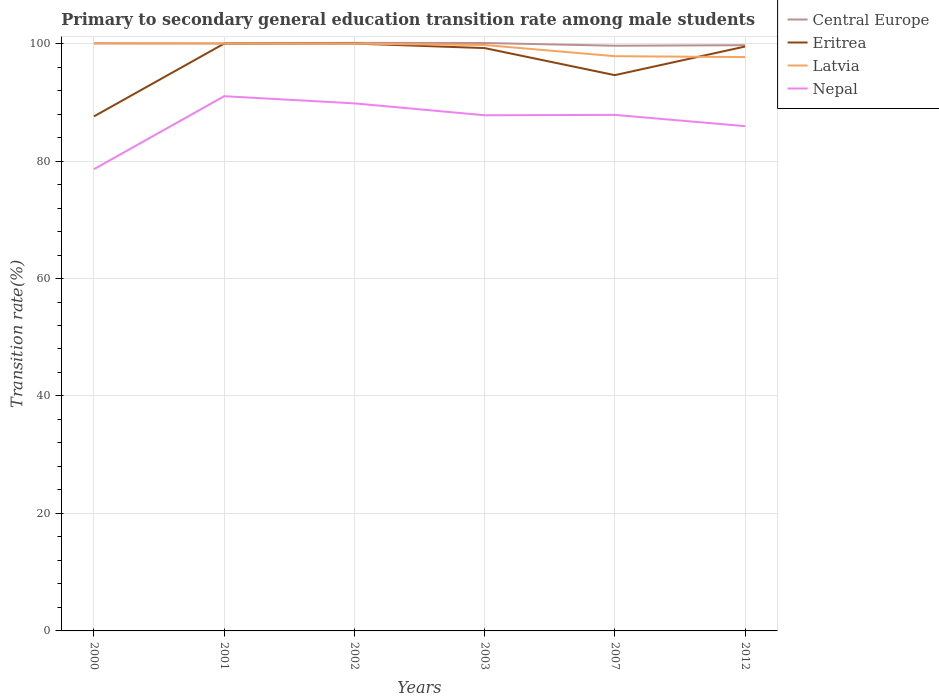How many different coloured lines are there?
Ensure brevity in your answer.  4. Does the line corresponding to Central Europe intersect with the line corresponding to Eritrea?
Ensure brevity in your answer.  No. Is the number of lines equal to the number of legend labels?
Offer a terse response. Yes. Across all years, what is the maximum transition rate in Eritrea?
Make the answer very short. 87.6. In which year was the transition rate in Latvia maximum?
Offer a terse response. 2012. What is the total transition rate in Eritrea in the graph?
Provide a succinct answer. 0.5. What is the difference between the highest and the second highest transition rate in Latvia?
Offer a very short reply. 2.3. Is the transition rate in Latvia strictly greater than the transition rate in Eritrea over the years?
Your answer should be compact. No. Are the values on the major ticks of Y-axis written in scientific E-notation?
Ensure brevity in your answer.  No. Does the graph contain grids?
Your answer should be compact. Yes. Where does the legend appear in the graph?
Ensure brevity in your answer.  Top right. How many legend labels are there?
Give a very brief answer. 4. What is the title of the graph?
Give a very brief answer. Primary to secondary general education transition rate among male students. Does "Trinidad and Tobago" appear as one of the legend labels in the graph?
Your answer should be compact. No. What is the label or title of the Y-axis?
Your response must be concise. Transition rate(%). What is the Transition rate(%) in Central Europe in 2000?
Your answer should be compact. 100.06. What is the Transition rate(%) of Eritrea in 2000?
Offer a very short reply. 87.6. What is the Transition rate(%) in Nepal in 2000?
Your response must be concise. 78.61. What is the Transition rate(%) in Central Europe in 2001?
Your response must be concise. 100.03. What is the Transition rate(%) in Nepal in 2001?
Keep it short and to the point. 91.04. What is the Transition rate(%) of Central Europe in 2002?
Your response must be concise. 100.12. What is the Transition rate(%) in Latvia in 2002?
Provide a succinct answer. 99.99. What is the Transition rate(%) in Nepal in 2002?
Offer a terse response. 89.82. What is the Transition rate(%) of Central Europe in 2003?
Keep it short and to the point. 100.1. What is the Transition rate(%) of Eritrea in 2003?
Give a very brief answer. 99.23. What is the Transition rate(%) of Latvia in 2003?
Offer a terse response. 99.76. What is the Transition rate(%) of Nepal in 2003?
Offer a very short reply. 87.8. What is the Transition rate(%) of Central Europe in 2007?
Provide a succinct answer. 99.63. What is the Transition rate(%) in Eritrea in 2007?
Provide a short and direct response. 94.62. What is the Transition rate(%) in Latvia in 2007?
Your response must be concise. 97.85. What is the Transition rate(%) of Nepal in 2007?
Offer a very short reply. 87.86. What is the Transition rate(%) of Central Europe in 2012?
Your response must be concise. 99.73. What is the Transition rate(%) of Eritrea in 2012?
Provide a succinct answer. 99.5. What is the Transition rate(%) of Latvia in 2012?
Ensure brevity in your answer.  97.7. What is the Transition rate(%) of Nepal in 2012?
Provide a short and direct response. 85.94. Across all years, what is the maximum Transition rate(%) in Central Europe?
Provide a succinct answer. 100.12. Across all years, what is the maximum Transition rate(%) of Eritrea?
Give a very brief answer. 100. Across all years, what is the maximum Transition rate(%) of Nepal?
Give a very brief answer. 91.04. Across all years, what is the minimum Transition rate(%) of Central Europe?
Keep it short and to the point. 99.63. Across all years, what is the minimum Transition rate(%) in Eritrea?
Offer a terse response. 87.6. Across all years, what is the minimum Transition rate(%) of Latvia?
Your response must be concise. 97.7. Across all years, what is the minimum Transition rate(%) in Nepal?
Keep it short and to the point. 78.61. What is the total Transition rate(%) in Central Europe in the graph?
Offer a very short reply. 599.67. What is the total Transition rate(%) in Eritrea in the graph?
Offer a very short reply. 580.96. What is the total Transition rate(%) of Latvia in the graph?
Offer a terse response. 595.3. What is the total Transition rate(%) in Nepal in the graph?
Give a very brief answer. 521.08. What is the difference between the Transition rate(%) in Central Europe in 2000 and that in 2001?
Give a very brief answer. 0.03. What is the difference between the Transition rate(%) in Eritrea in 2000 and that in 2001?
Ensure brevity in your answer.  -12.4. What is the difference between the Transition rate(%) in Nepal in 2000 and that in 2001?
Your answer should be very brief. -12.43. What is the difference between the Transition rate(%) in Central Europe in 2000 and that in 2002?
Offer a very short reply. -0.05. What is the difference between the Transition rate(%) in Eritrea in 2000 and that in 2002?
Your answer should be compact. -12.4. What is the difference between the Transition rate(%) in Latvia in 2000 and that in 2002?
Keep it short and to the point. 0.01. What is the difference between the Transition rate(%) of Nepal in 2000 and that in 2002?
Ensure brevity in your answer.  -11.21. What is the difference between the Transition rate(%) of Central Europe in 2000 and that in 2003?
Your answer should be very brief. -0.04. What is the difference between the Transition rate(%) of Eritrea in 2000 and that in 2003?
Make the answer very short. -11.63. What is the difference between the Transition rate(%) of Latvia in 2000 and that in 2003?
Give a very brief answer. 0.24. What is the difference between the Transition rate(%) of Nepal in 2000 and that in 2003?
Make the answer very short. -9.18. What is the difference between the Transition rate(%) in Central Europe in 2000 and that in 2007?
Your response must be concise. 0.43. What is the difference between the Transition rate(%) in Eritrea in 2000 and that in 2007?
Keep it short and to the point. -7.02. What is the difference between the Transition rate(%) of Latvia in 2000 and that in 2007?
Your answer should be compact. 2.15. What is the difference between the Transition rate(%) in Nepal in 2000 and that in 2007?
Ensure brevity in your answer.  -9.25. What is the difference between the Transition rate(%) in Central Europe in 2000 and that in 2012?
Keep it short and to the point. 0.34. What is the difference between the Transition rate(%) of Eritrea in 2000 and that in 2012?
Your answer should be very brief. -11.89. What is the difference between the Transition rate(%) of Latvia in 2000 and that in 2012?
Give a very brief answer. 2.3. What is the difference between the Transition rate(%) of Nepal in 2000 and that in 2012?
Keep it short and to the point. -7.33. What is the difference between the Transition rate(%) of Central Europe in 2001 and that in 2002?
Your answer should be very brief. -0.09. What is the difference between the Transition rate(%) in Latvia in 2001 and that in 2002?
Provide a succinct answer. 0.01. What is the difference between the Transition rate(%) of Nepal in 2001 and that in 2002?
Offer a very short reply. 1.22. What is the difference between the Transition rate(%) of Central Europe in 2001 and that in 2003?
Your answer should be very brief. -0.07. What is the difference between the Transition rate(%) in Eritrea in 2001 and that in 2003?
Offer a very short reply. 0.77. What is the difference between the Transition rate(%) in Latvia in 2001 and that in 2003?
Provide a succinct answer. 0.24. What is the difference between the Transition rate(%) of Nepal in 2001 and that in 2003?
Your answer should be very brief. 3.25. What is the difference between the Transition rate(%) in Central Europe in 2001 and that in 2007?
Offer a terse response. 0.4. What is the difference between the Transition rate(%) of Eritrea in 2001 and that in 2007?
Provide a short and direct response. 5.38. What is the difference between the Transition rate(%) in Latvia in 2001 and that in 2007?
Provide a succinct answer. 2.15. What is the difference between the Transition rate(%) in Nepal in 2001 and that in 2007?
Offer a terse response. 3.18. What is the difference between the Transition rate(%) of Central Europe in 2001 and that in 2012?
Make the answer very short. 0.3. What is the difference between the Transition rate(%) of Eritrea in 2001 and that in 2012?
Provide a short and direct response. 0.5. What is the difference between the Transition rate(%) of Latvia in 2001 and that in 2012?
Your answer should be very brief. 2.3. What is the difference between the Transition rate(%) of Nepal in 2001 and that in 2012?
Provide a short and direct response. 5.1. What is the difference between the Transition rate(%) of Central Europe in 2002 and that in 2003?
Ensure brevity in your answer.  0.02. What is the difference between the Transition rate(%) in Eritrea in 2002 and that in 2003?
Provide a succinct answer. 0.77. What is the difference between the Transition rate(%) in Latvia in 2002 and that in 2003?
Offer a very short reply. 0.23. What is the difference between the Transition rate(%) in Nepal in 2002 and that in 2003?
Provide a short and direct response. 2.02. What is the difference between the Transition rate(%) in Central Europe in 2002 and that in 2007?
Your response must be concise. 0.48. What is the difference between the Transition rate(%) of Eritrea in 2002 and that in 2007?
Keep it short and to the point. 5.38. What is the difference between the Transition rate(%) of Latvia in 2002 and that in 2007?
Your answer should be very brief. 2.13. What is the difference between the Transition rate(%) of Nepal in 2002 and that in 2007?
Offer a very short reply. 1.96. What is the difference between the Transition rate(%) of Central Europe in 2002 and that in 2012?
Give a very brief answer. 0.39. What is the difference between the Transition rate(%) in Eritrea in 2002 and that in 2012?
Make the answer very short. 0.5. What is the difference between the Transition rate(%) of Latvia in 2002 and that in 2012?
Offer a terse response. 2.29. What is the difference between the Transition rate(%) of Nepal in 2002 and that in 2012?
Ensure brevity in your answer.  3.88. What is the difference between the Transition rate(%) of Central Europe in 2003 and that in 2007?
Provide a short and direct response. 0.47. What is the difference between the Transition rate(%) of Eritrea in 2003 and that in 2007?
Provide a short and direct response. 4.61. What is the difference between the Transition rate(%) in Latvia in 2003 and that in 2007?
Your answer should be compact. 1.91. What is the difference between the Transition rate(%) of Nepal in 2003 and that in 2007?
Ensure brevity in your answer.  -0.06. What is the difference between the Transition rate(%) in Central Europe in 2003 and that in 2012?
Your answer should be compact. 0.37. What is the difference between the Transition rate(%) in Eritrea in 2003 and that in 2012?
Ensure brevity in your answer.  -0.26. What is the difference between the Transition rate(%) of Latvia in 2003 and that in 2012?
Offer a very short reply. 2.06. What is the difference between the Transition rate(%) of Nepal in 2003 and that in 2012?
Offer a terse response. 1.85. What is the difference between the Transition rate(%) of Central Europe in 2007 and that in 2012?
Offer a terse response. -0.09. What is the difference between the Transition rate(%) in Eritrea in 2007 and that in 2012?
Give a very brief answer. -4.87. What is the difference between the Transition rate(%) in Latvia in 2007 and that in 2012?
Your answer should be compact. 0.15. What is the difference between the Transition rate(%) in Nepal in 2007 and that in 2012?
Provide a succinct answer. 1.92. What is the difference between the Transition rate(%) in Central Europe in 2000 and the Transition rate(%) in Eritrea in 2001?
Offer a terse response. 0.06. What is the difference between the Transition rate(%) in Central Europe in 2000 and the Transition rate(%) in Latvia in 2001?
Keep it short and to the point. 0.06. What is the difference between the Transition rate(%) of Central Europe in 2000 and the Transition rate(%) of Nepal in 2001?
Offer a very short reply. 9.02. What is the difference between the Transition rate(%) in Eritrea in 2000 and the Transition rate(%) in Latvia in 2001?
Offer a terse response. -12.4. What is the difference between the Transition rate(%) of Eritrea in 2000 and the Transition rate(%) of Nepal in 2001?
Provide a short and direct response. -3.44. What is the difference between the Transition rate(%) in Latvia in 2000 and the Transition rate(%) in Nepal in 2001?
Offer a terse response. 8.96. What is the difference between the Transition rate(%) of Central Europe in 2000 and the Transition rate(%) of Eritrea in 2002?
Your answer should be compact. 0.06. What is the difference between the Transition rate(%) in Central Europe in 2000 and the Transition rate(%) in Latvia in 2002?
Your answer should be compact. 0.08. What is the difference between the Transition rate(%) in Central Europe in 2000 and the Transition rate(%) in Nepal in 2002?
Ensure brevity in your answer.  10.24. What is the difference between the Transition rate(%) of Eritrea in 2000 and the Transition rate(%) of Latvia in 2002?
Keep it short and to the point. -12.38. What is the difference between the Transition rate(%) of Eritrea in 2000 and the Transition rate(%) of Nepal in 2002?
Give a very brief answer. -2.22. What is the difference between the Transition rate(%) in Latvia in 2000 and the Transition rate(%) in Nepal in 2002?
Provide a short and direct response. 10.18. What is the difference between the Transition rate(%) in Central Europe in 2000 and the Transition rate(%) in Eritrea in 2003?
Make the answer very short. 0.83. What is the difference between the Transition rate(%) in Central Europe in 2000 and the Transition rate(%) in Latvia in 2003?
Give a very brief answer. 0.3. What is the difference between the Transition rate(%) in Central Europe in 2000 and the Transition rate(%) in Nepal in 2003?
Keep it short and to the point. 12.27. What is the difference between the Transition rate(%) in Eritrea in 2000 and the Transition rate(%) in Latvia in 2003?
Give a very brief answer. -12.15. What is the difference between the Transition rate(%) in Eritrea in 2000 and the Transition rate(%) in Nepal in 2003?
Make the answer very short. -0.19. What is the difference between the Transition rate(%) in Latvia in 2000 and the Transition rate(%) in Nepal in 2003?
Your answer should be very brief. 12.2. What is the difference between the Transition rate(%) in Central Europe in 2000 and the Transition rate(%) in Eritrea in 2007?
Provide a short and direct response. 5.44. What is the difference between the Transition rate(%) of Central Europe in 2000 and the Transition rate(%) of Latvia in 2007?
Offer a very short reply. 2.21. What is the difference between the Transition rate(%) of Central Europe in 2000 and the Transition rate(%) of Nepal in 2007?
Your answer should be compact. 12.2. What is the difference between the Transition rate(%) of Eritrea in 2000 and the Transition rate(%) of Latvia in 2007?
Your response must be concise. -10.25. What is the difference between the Transition rate(%) in Eritrea in 2000 and the Transition rate(%) in Nepal in 2007?
Your response must be concise. -0.26. What is the difference between the Transition rate(%) of Latvia in 2000 and the Transition rate(%) of Nepal in 2007?
Offer a very short reply. 12.14. What is the difference between the Transition rate(%) in Central Europe in 2000 and the Transition rate(%) in Eritrea in 2012?
Your answer should be compact. 0.57. What is the difference between the Transition rate(%) of Central Europe in 2000 and the Transition rate(%) of Latvia in 2012?
Provide a short and direct response. 2.37. What is the difference between the Transition rate(%) in Central Europe in 2000 and the Transition rate(%) in Nepal in 2012?
Your response must be concise. 14.12. What is the difference between the Transition rate(%) in Eritrea in 2000 and the Transition rate(%) in Latvia in 2012?
Offer a terse response. -10.09. What is the difference between the Transition rate(%) of Eritrea in 2000 and the Transition rate(%) of Nepal in 2012?
Your response must be concise. 1.66. What is the difference between the Transition rate(%) of Latvia in 2000 and the Transition rate(%) of Nepal in 2012?
Make the answer very short. 14.06. What is the difference between the Transition rate(%) of Central Europe in 2001 and the Transition rate(%) of Eritrea in 2002?
Offer a very short reply. 0.03. What is the difference between the Transition rate(%) in Central Europe in 2001 and the Transition rate(%) in Latvia in 2002?
Ensure brevity in your answer.  0.04. What is the difference between the Transition rate(%) of Central Europe in 2001 and the Transition rate(%) of Nepal in 2002?
Your response must be concise. 10.21. What is the difference between the Transition rate(%) of Eritrea in 2001 and the Transition rate(%) of Latvia in 2002?
Your response must be concise. 0.01. What is the difference between the Transition rate(%) in Eritrea in 2001 and the Transition rate(%) in Nepal in 2002?
Provide a succinct answer. 10.18. What is the difference between the Transition rate(%) of Latvia in 2001 and the Transition rate(%) of Nepal in 2002?
Provide a succinct answer. 10.18. What is the difference between the Transition rate(%) in Central Europe in 2001 and the Transition rate(%) in Eritrea in 2003?
Make the answer very short. 0.8. What is the difference between the Transition rate(%) of Central Europe in 2001 and the Transition rate(%) of Latvia in 2003?
Offer a terse response. 0.27. What is the difference between the Transition rate(%) in Central Europe in 2001 and the Transition rate(%) in Nepal in 2003?
Give a very brief answer. 12.23. What is the difference between the Transition rate(%) in Eritrea in 2001 and the Transition rate(%) in Latvia in 2003?
Give a very brief answer. 0.24. What is the difference between the Transition rate(%) of Eritrea in 2001 and the Transition rate(%) of Nepal in 2003?
Offer a terse response. 12.2. What is the difference between the Transition rate(%) in Latvia in 2001 and the Transition rate(%) in Nepal in 2003?
Offer a terse response. 12.2. What is the difference between the Transition rate(%) of Central Europe in 2001 and the Transition rate(%) of Eritrea in 2007?
Offer a terse response. 5.41. What is the difference between the Transition rate(%) of Central Europe in 2001 and the Transition rate(%) of Latvia in 2007?
Ensure brevity in your answer.  2.18. What is the difference between the Transition rate(%) of Central Europe in 2001 and the Transition rate(%) of Nepal in 2007?
Your answer should be compact. 12.17. What is the difference between the Transition rate(%) in Eritrea in 2001 and the Transition rate(%) in Latvia in 2007?
Make the answer very short. 2.15. What is the difference between the Transition rate(%) in Eritrea in 2001 and the Transition rate(%) in Nepal in 2007?
Keep it short and to the point. 12.14. What is the difference between the Transition rate(%) in Latvia in 2001 and the Transition rate(%) in Nepal in 2007?
Make the answer very short. 12.14. What is the difference between the Transition rate(%) of Central Europe in 2001 and the Transition rate(%) of Eritrea in 2012?
Keep it short and to the point. 0.53. What is the difference between the Transition rate(%) of Central Europe in 2001 and the Transition rate(%) of Latvia in 2012?
Provide a succinct answer. 2.33. What is the difference between the Transition rate(%) of Central Europe in 2001 and the Transition rate(%) of Nepal in 2012?
Offer a very short reply. 14.09. What is the difference between the Transition rate(%) of Eritrea in 2001 and the Transition rate(%) of Latvia in 2012?
Offer a terse response. 2.3. What is the difference between the Transition rate(%) of Eritrea in 2001 and the Transition rate(%) of Nepal in 2012?
Offer a terse response. 14.06. What is the difference between the Transition rate(%) in Latvia in 2001 and the Transition rate(%) in Nepal in 2012?
Give a very brief answer. 14.06. What is the difference between the Transition rate(%) of Central Europe in 2002 and the Transition rate(%) of Eritrea in 2003?
Make the answer very short. 0.88. What is the difference between the Transition rate(%) of Central Europe in 2002 and the Transition rate(%) of Latvia in 2003?
Give a very brief answer. 0.36. What is the difference between the Transition rate(%) of Central Europe in 2002 and the Transition rate(%) of Nepal in 2003?
Provide a succinct answer. 12.32. What is the difference between the Transition rate(%) of Eritrea in 2002 and the Transition rate(%) of Latvia in 2003?
Keep it short and to the point. 0.24. What is the difference between the Transition rate(%) of Eritrea in 2002 and the Transition rate(%) of Nepal in 2003?
Ensure brevity in your answer.  12.2. What is the difference between the Transition rate(%) in Latvia in 2002 and the Transition rate(%) in Nepal in 2003?
Ensure brevity in your answer.  12.19. What is the difference between the Transition rate(%) of Central Europe in 2002 and the Transition rate(%) of Eritrea in 2007?
Your response must be concise. 5.49. What is the difference between the Transition rate(%) in Central Europe in 2002 and the Transition rate(%) in Latvia in 2007?
Offer a terse response. 2.27. What is the difference between the Transition rate(%) in Central Europe in 2002 and the Transition rate(%) in Nepal in 2007?
Offer a terse response. 12.26. What is the difference between the Transition rate(%) of Eritrea in 2002 and the Transition rate(%) of Latvia in 2007?
Give a very brief answer. 2.15. What is the difference between the Transition rate(%) in Eritrea in 2002 and the Transition rate(%) in Nepal in 2007?
Your answer should be very brief. 12.14. What is the difference between the Transition rate(%) in Latvia in 2002 and the Transition rate(%) in Nepal in 2007?
Provide a short and direct response. 12.13. What is the difference between the Transition rate(%) in Central Europe in 2002 and the Transition rate(%) in Eritrea in 2012?
Give a very brief answer. 0.62. What is the difference between the Transition rate(%) of Central Europe in 2002 and the Transition rate(%) of Latvia in 2012?
Your answer should be very brief. 2.42. What is the difference between the Transition rate(%) of Central Europe in 2002 and the Transition rate(%) of Nepal in 2012?
Ensure brevity in your answer.  14.18. What is the difference between the Transition rate(%) of Eritrea in 2002 and the Transition rate(%) of Latvia in 2012?
Your response must be concise. 2.3. What is the difference between the Transition rate(%) of Eritrea in 2002 and the Transition rate(%) of Nepal in 2012?
Provide a succinct answer. 14.06. What is the difference between the Transition rate(%) of Latvia in 2002 and the Transition rate(%) of Nepal in 2012?
Your answer should be compact. 14.05. What is the difference between the Transition rate(%) of Central Europe in 2003 and the Transition rate(%) of Eritrea in 2007?
Give a very brief answer. 5.47. What is the difference between the Transition rate(%) in Central Europe in 2003 and the Transition rate(%) in Latvia in 2007?
Provide a succinct answer. 2.25. What is the difference between the Transition rate(%) of Central Europe in 2003 and the Transition rate(%) of Nepal in 2007?
Your answer should be very brief. 12.24. What is the difference between the Transition rate(%) in Eritrea in 2003 and the Transition rate(%) in Latvia in 2007?
Your answer should be very brief. 1.38. What is the difference between the Transition rate(%) in Eritrea in 2003 and the Transition rate(%) in Nepal in 2007?
Give a very brief answer. 11.37. What is the difference between the Transition rate(%) in Latvia in 2003 and the Transition rate(%) in Nepal in 2007?
Keep it short and to the point. 11.9. What is the difference between the Transition rate(%) of Central Europe in 2003 and the Transition rate(%) of Eritrea in 2012?
Provide a succinct answer. 0.6. What is the difference between the Transition rate(%) in Central Europe in 2003 and the Transition rate(%) in Latvia in 2012?
Ensure brevity in your answer.  2.4. What is the difference between the Transition rate(%) of Central Europe in 2003 and the Transition rate(%) of Nepal in 2012?
Your answer should be compact. 14.16. What is the difference between the Transition rate(%) in Eritrea in 2003 and the Transition rate(%) in Latvia in 2012?
Ensure brevity in your answer.  1.54. What is the difference between the Transition rate(%) in Eritrea in 2003 and the Transition rate(%) in Nepal in 2012?
Ensure brevity in your answer.  13.29. What is the difference between the Transition rate(%) in Latvia in 2003 and the Transition rate(%) in Nepal in 2012?
Provide a short and direct response. 13.82. What is the difference between the Transition rate(%) in Central Europe in 2007 and the Transition rate(%) in Eritrea in 2012?
Offer a terse response. 0.14. What is the difference between the Transition rate(%) in Central Europe in 2007 and the Transition rate(%) in Latvia in 2012?
Your answer should be compact. 1.93. What is the difference between the Transition rate(%) of Central Europe in 2007 and the Transition rate(%) of Nepal in 2012?
Make the answer very short. 13.69. What is the difference between the Transition rate(%) in Eritrea in 2007 and the Transition rate(%) in Latvia in 2012?
Give a very brief answer. -3.07. What is the difference between the Transition rate(%) of Eritrea in 2007 and the Transition rate(%) of Nepal in 2012?
Ensure brevity in your answer.  8.68. What is the difference between the Transition rate(%) in Latvia in 2007 and the Transition rate(%) in Nepal in 2012?
Provide a succinct answer. 11.91. What is the average Transition rate(%) of Central Europe per year?
Offer a terse response. 99.95. What is the average Transition rate(%) in Eritrea per year?
Your answer should be compact. 96.83. What is the average Transition rate(%) in Latvia per year?
Provide a short and direct response. 99.22. What is the average Transition rate(%) in Nepal per year?
Provide a short and direct response. 86.85. In the year 2000, what is the difference between the Transition rate(%) of Central Europe and Transition rate(%) of Eritrea?
Your response must be concise. 12.46. In the year 2000, what is the difference between the Transition rate(%) of Central Europe and Transition rate(%) of Latvia?
Your answer should be compact. 0.06. In the year 2000, what is the difference between the Transition rate(%) in Central Europe and Transition rate(%) in Nepal?
Give a very brief answer. 21.45. In the year 2000, what is the difference between the Transition rate(%) of Eritrea and Transition rate(%) of Latvia?
Your response must be concise. -12.4. In the year 2000, what is the difference between the Transition rate(%) in Eritrea and Transition rate(%) in Nepal?
Make the answer very short. 8.99. In the year 2000, what is the difference between the Transition rate(%) in Latvia and Transition rate(%) in Nepal?
Give a very brief answer. 21.39. In the year 2001, what is the difference between the Transition rate(%) of Central Europe and Transition rate(%) of Eritrea?
Ensure brevity in your answer.  0.03. In the year 2001, what is the difference between the Transition rate(%) in Central Europe and Transition rate(%) in Latvia?
Offer a terse response. 0.03. In the year 2001, what is the difference between the Transition rate(%) in Central Europe and Transition rate(%) in Nepal?
Make the answer very short. 8.99. In the year 2001, what is the difference between the Transition rate(%) in Eritrea and Transition rate(%) in Latvia?
Your answer should be very brief. 0. In the year 2001, what is the difference between the Transition rate(%) of Eritrea and Transition rate(%) of Nepal?
Your answer should be very brief. 8.96. In the year 2001, what is the difference between the Transition rate(%) of Latvia and Transition rate(%) of Nepal?
Your response must be concise. 8.96. In the year 2002, what is the difference between the Transition rate(%) of Central Europe and Transition rate(%) of Eritrea?
Keep it short and to the point. 0.12. In the year 2002, what is the difference between the Transition rate(%) in Central Europe and Transition rate(%) in Latvia?
Your answer should be very brief. 0.13. In the year 2002, what is the difference between the Transition rate(%) of Central Europe and Transition rate(%) of Nepal?
Offer a terse response. 10.3. In the year 2002, what is the difference between the Transition rate(%) in Eritrea and Transition rate(%) in Latvia?
Give a very brief answer. 0.01. In the year 2002, what is the difference between the Transition rate(%) in Eritrea and Transition rate(%) in Nepal?
Provide a short and direct response. 10.18. In the year 2002, what is the difference between the Transition rate(%) of Latvia and Transition rate(%) of Nepal?
Provide a short and direct response. 10.17. In the year 2003, what is the difference between the Transition rate(%) in Central Europe and Transition rate(%) in Eritrea?
Make the answer very short. 0.86. In the year 2003, what is the difference between the Transition rate(%) in Central Europe and Transition rate(%) in Latvia?
Offer a terse response. 0.34. In the year 2003, what is the difference between the Transition rate(%) in Central Europe and Transition rate(%) in Nepal?
Provide a short and direct response. 12.3. In the year 2003, what is the difference between the Transition rate(%) in Eritrea and Transition rate(%) in Latvia?
Offer a terse response. -0.53. In the year 2003, what is the difference between the Transition rate(%) of Eritrea and Transition rate(%) of Nepal?
Provide a succinct answer. 11.44. In the year 2003, what is the difference between the Transition rate(%) of Latvia and Transition rate(%) of Nepal?
Your answer should be compact. 11.96. In the year 2007, what is the difference between the Transition rate(%) in Central Europe and Transition rate(%) in Eritrea?
Ensure brevity in your answer.  5.01. In the year 2007, what is the difference between the Transition rate(%) of Central Europe and Transition rate(%) of Latvia?
Keep it short and to the point. 1.78. In the year 2007, what is the difference between the Transition rate(%) in Central Europe and Transition rate(%) in Nepal?
Offer a terse response. 11.77. In the year 2007, what is the difference between the Transition rate(%) in Eritrea and Transition rate(%) in Latvia?
Offer a very short reply. -3.23. In the year 2007, what is the difference between the Transition rate(%) of Eritrea and Transition rate(%) of Nepal?
Give a very brief answer. 6.76. In the year 2007, what is the difference between the Transition rate(%) of Latvia and Transition rate(%) of Nepal?
Make the answer very short. 9.99. In the year 2012, what is the difference between the Transition rate(%) of Central Europe and Transition rate(%) of Eritrea?
Keep it short and to the point. 0.23. In the year 2012, what is the difference between the Transition rate(%) in Central Europe and Transition rate(%) in Latvia?
Provide a short and direct response. 2.03. In the year 2012, what is the difference between the Transition rate(%) in Central Europe and Transition rate(%) in Nepal?
Your answer should be very brief. 13.78. In the year 2012, what is the difference between the Transition rate(%) in Eritrea and Transition rate(%) in Latvia?
Ensure brevity in your answer.  1.8. In the year 2012, what is the difference between the Transition rate(%) of Eritrea and Transition rate(%) of Nepal?
Provide a short and direct response. 13.55. In the year 2012, what is the difference between the Transition rate(%) in Latvia and Transition rate(%) in Nepal?
Give a very brief answer. 11.76. What is the ratio of the Transition rate(%) in Central Europe in 2000 to that in 2001?
Keep it short and to the point. 1. What is the ratio of the Transition rate(%) of Eritrea in 2000 to that in 2001?
Offer a very short reply. 0.88. What is the ratio of the Transition rate(%) of Nepal in 2000 to that in 2001?
Your response must be concise. 0.86. What is the ratio of the Transition rate(%) in Eritrea in 2000 to that in 2002?
Make the answer very short. 0.88. What is the ratio of the Transition rate(%) of Nepal in 2000 to that in 2002?
Make the answer very short. 0.88. What is the ratio of the Transition rate(%) of Central Europe in 2000 to that in 2003?
Make the answer very short. 1. What is the ratio of the Transition rate(%) of Eritrea in 2000 to that in 2003?
Provide a short and direct response. 0.88. What is the ratio of the Transition rate(%) in Nepal in 2000 to that in 2003?
Provide a short and direct response. 0.9. What is the ratio of the Transition rate(%) of Central Europe in 2000 to that in 2007?
Your answer should be very brief. 1. What is the ratio of the Transition rate(%) of Eritrea in 2000 to that in 2007?
Provide a succinct answer. 0.93. What is the ratio of the Transition rate(%) in Latvia in 2000 to that in 2007?
Your answer should be very brief. 1.02. What is the ratio of the Transition rate(%) in Nepal in 2000 to that in 2007?
Your answer should be compact. 0.89. What is the ratio of the Transition rate(%) in Eritrea in 2000 to that in 2012?
Make the answer very short. 0.88. What is the ratio of the Transition rate(%) in Latvia in 2000 to that in 2012?
Keep it short and to the point. 1.02. What is the ratio of the Transition rate(%) of Nepal in 2000 to that in 2012?
Your response must be concise. 0.91. What is the ratio of the Transition rate(%) of Latvia in 2001 to that in 2002?
Provide a short and direct response. 1. What is the ratio of the Transition rate(%) of Nepal in 2001 to that in 2002?
Keep it short and to the point. 1.01. What is the ratio of the Transition rate(%) of Eritrea in 2001 to that in 2003?
Offer a terse response. 1.01. What is the ratio of the Transition rate(%) in Eritrea in 2001 to that in 2007?
Offer a terse response. 1.06. What is the ratio of the Transition rate(%) in Latvia in 2001 to that in 2007?
Give a very brief answer. 1.02. What is the ratio of the Transition rate(%) in Nepal in 2001 to that in 2007?
Provide a short and direct response. 1.04. What is the ratio of the Transition rate(%) of Central Europe in 2001 to that in 2012?
Keep it short and to the point. 1. What is the ratio of the Transition rate(%) in Latvia in 2001 to that in 2012?
Offer a terse response. 1.02. What is the ratio of the Transition rate(%) of Nepal in 2001 to that in 2012?
Provide a short and direct response. 1.06. What is the ratio of the Transition rate(%) of Central Europe in 2002 to that in 2003?
Provide a succinct answer. 1. What is the ratio of the Transition rate(%) of Eritrea in 2002 to that in 2003?
Provide a succinct answer. 1.01. What is the ratio of the Transition rate(%) in Nepal in 2002 to that in 2003?
Your response must be concise. 1.02. What is the ratio of the Transition rate(%) in Central Europe in 2002 to that in 2007?
Offer a terse response. 1. What is the ratio of the Transition rate(%) in Eritrea in 2002 to that in 2007?
Provide a short and direct response. 1.06. What is the ratio of the Transition rate(%) in Latvia in 2002 to that in 2007?
Ensure brevity in your answer.  1.02. What is the ratio of the Transition rate(%) in Nepal in 2002 to that in 2007?
Your answer should be very brief. 1.02. What is the ratio of the Transition rate(%) in Central Europe in 2002 to that in 2012?
Keep it short and to the point. 1. What is the ratio of the Transition rate(%) of Eritrea in 2002 to that in 2012?
Provide a short and direct response. 1.01. What is the ratio of the Transition rate(%) of Latvia in 2002 to that in 2012?
Provide a short and direct response. 1.02. What is the ratio of the Transition rate(%) in Nepal in 2002 to that in 2012?
Offer a very short reply. 1.05. What is the ratio of the Transition rate(%) in Central Europe in 2003 to that in 2007?
Your answer should be very brief. 1. What is the ratio of the Transition rate(%) of Eritrea in 2003 to that in 2007?
Provide a succinct answer. 1.05. What is the ratio of the Transition rate(%) of Latvia in 2003 to that in 2007?
Ensure brevity in your answer.  1.02. What is the ratio of the Transition rate(%) in Nepal in 2003 to that in 2007?
Ensure brevity in your answer.  1. What is the ratio of the Transition rate(%) in Central Europe in 2003 to that in 2012?
Your answer should be very brief. 1. What is the ratio of the Transition rate(%) of Eritrea in 2003 to that in 2012?
Your response must be concise. 1. What is the ratio of the Transition rate(%) in Latvia in 2003 to that in 2012?
Give a very brief answer. 1.02. What is the ratio of the Transition rate(%) in Nepal in 2003 to that in 2012?
Keep it short and to the point. 1.02. What is the ratio of the Transition rate(%) of Central Europe in 2007 to that in 2012?
Provide a succinct answer. 1. What is the ratio of the Transition rate(%) of Eritrea in 2007 to that in 2012?
Ensure brevity in your answer.  0.95. What is the ratio of the Transition rate(%) in Nepal in 2007 to that in 2012?
Ensure brevity in your answer.  1.02. What is the difference between the highest and the second highest Transition rate(%) in Central Europe?
Your answer should be compact. 0.02. What is the difference between the highest and the second highest Transition rate(%) of Latvia?
Keep it short and to the point. 0. What is the difference between the highest and the second highest Transition rate(%) in Nepal?
Ensure brevity in your answer.  1.22. What is the difference between the highest and the lowest Transition rate(%) in Central Europe?
Make the answer very short. 0.48. What is the difference between the highest and the lowest Transition rate(%) of Eritrea?
Provide a short and direct response. 12.4. What is the difference between the highest and the lowest Transition rate(%) in Latvia?
Offer a very short reply. 2.3. What is the difference between the highest and the lowest Transition rate(%) of Nepal?
Offer a terse response. 12.43. 